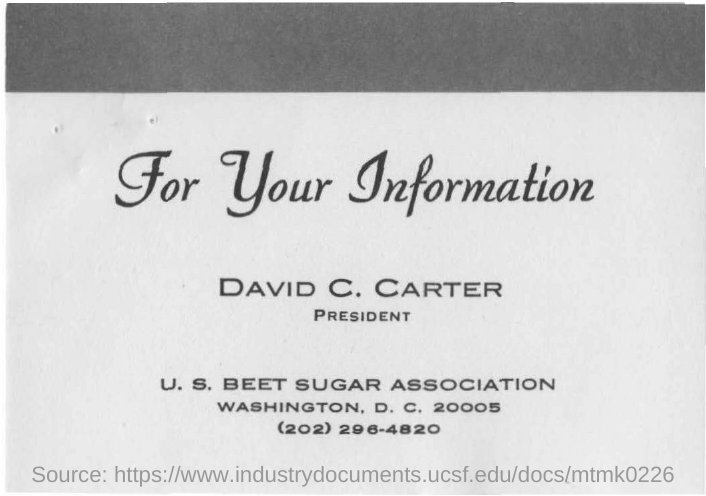Who is the PRESIDENT?
Keep it short and to the point. DAVID C. CARTER. What is the phone number of U. S. BEET SUGAR ASSOCIATION?
Offer a terse response. (202) 296-4820. 